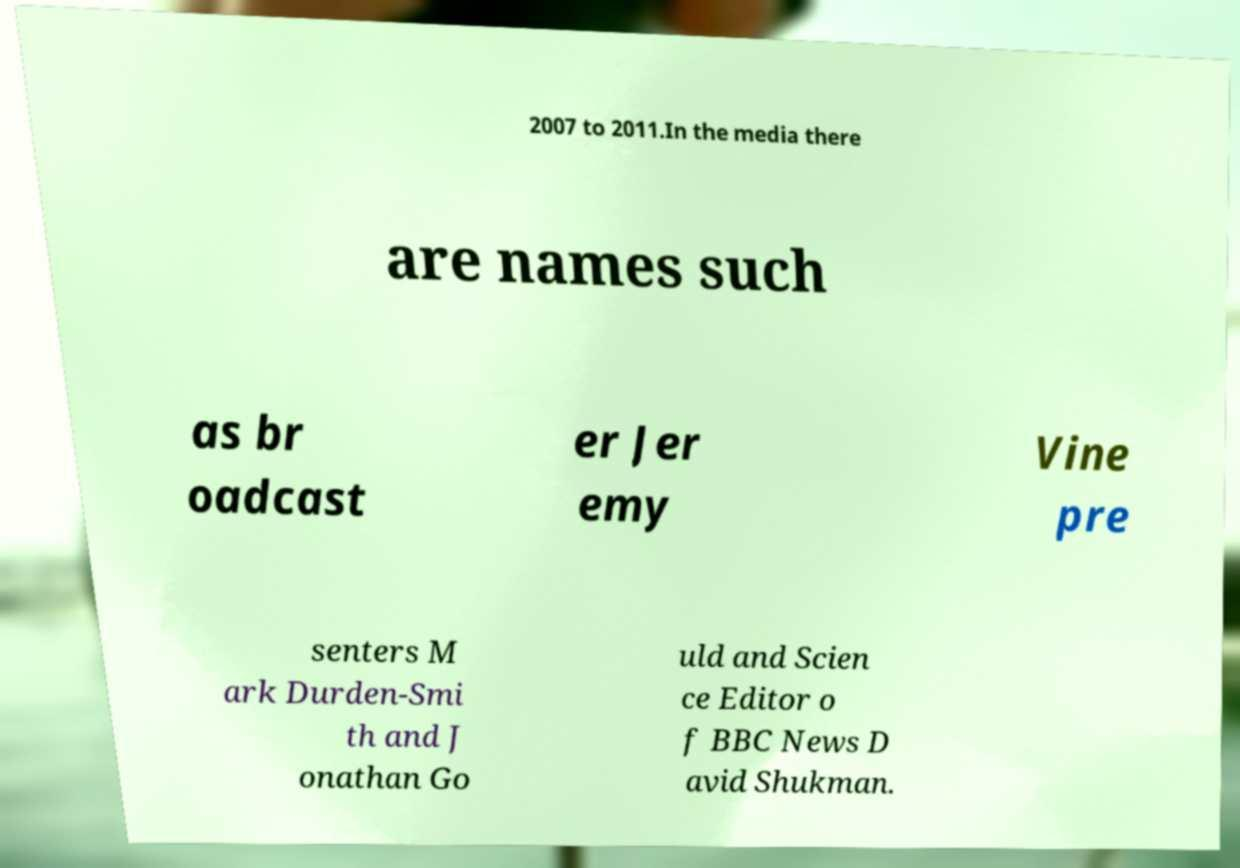Can you read and provide the text displayed in the image?This photo seems to have some interesting text. Can you extract and type it out for me? 2007 to 2011.In the media there are names such as br oadcast er Jer emy Vine pre senters M ark Durden-Smi th and J onathan Go uld and Scien ce Editor o f BBC News D avid Shukman. 